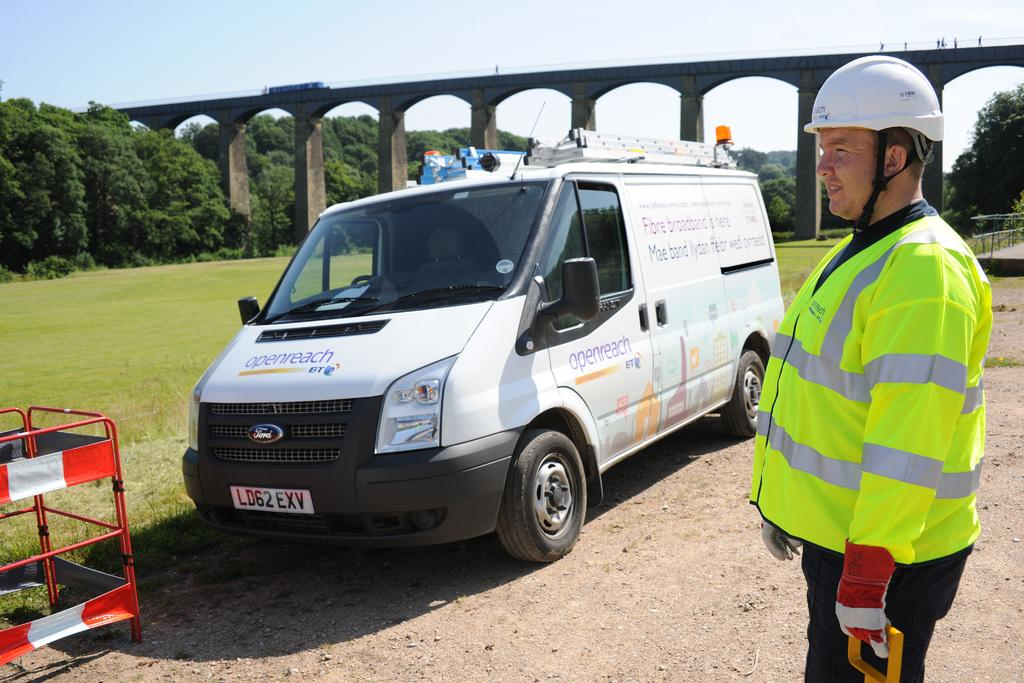<image>
Give a short and clear explanation of the subsequent image. A man in safety attire is standing near a Ford van. 